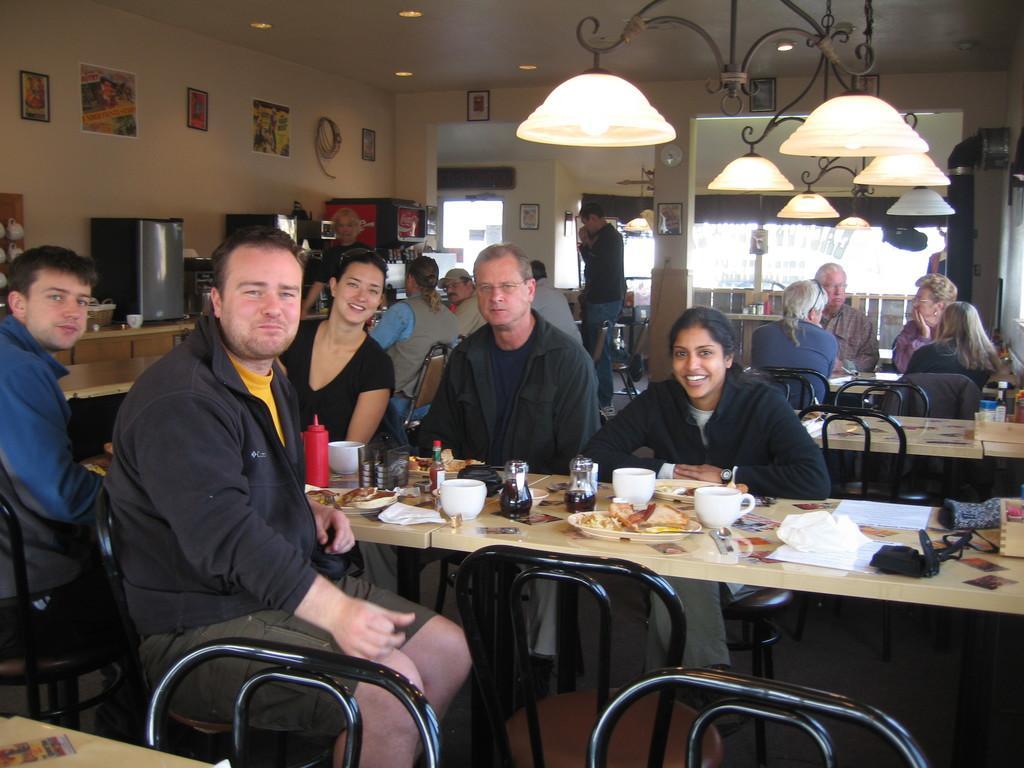How would you summarize this image in a sentence or two? In the image we can see there are lot of people who are sitting and in front of them there is a table on which there is a bowl, ketchup bottle and in plate there are food items. 